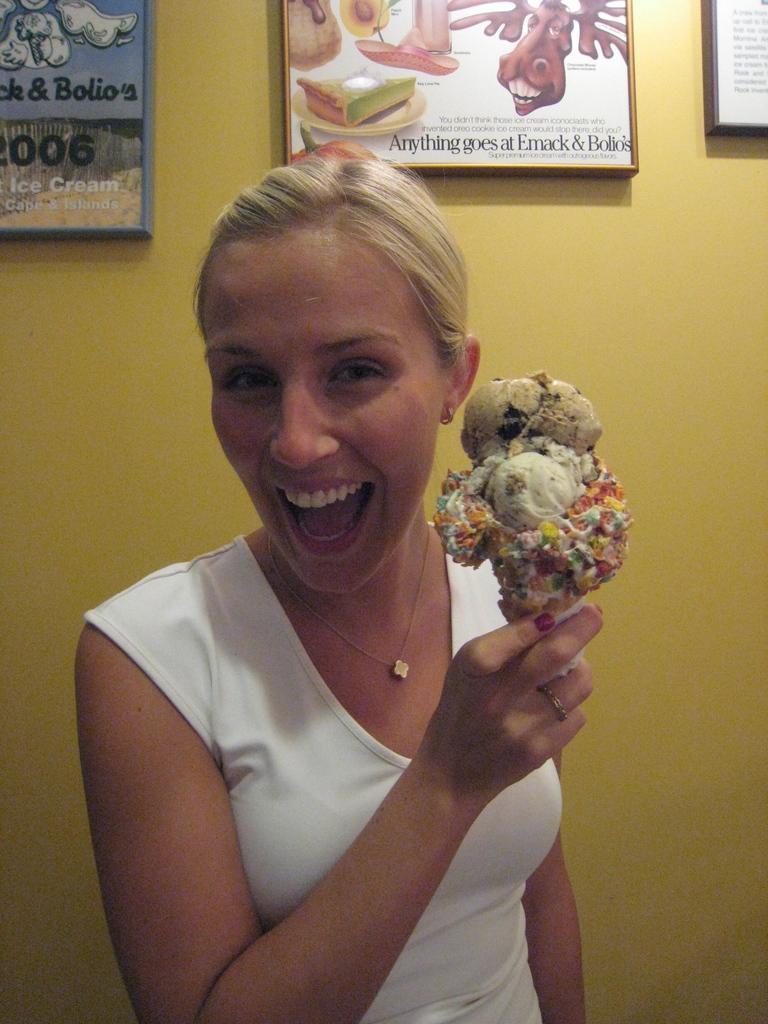Please provide a concise description of this image. In this picture there is a woman wearing a white top and holding an ice-cream. In the background there is a wall with frames. 